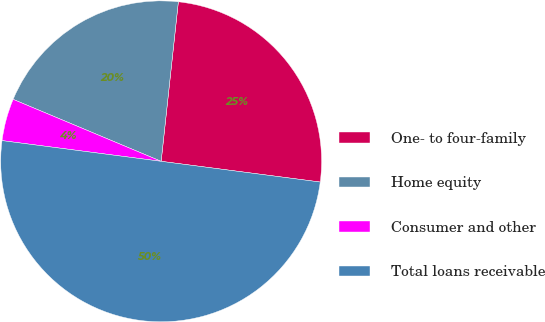Convert chart. <chart><loc_0><loc_0><loc_500><loc_500><pie_chart><fcel>One- to four-family<fcel>Home equity<fcel>Consumer and other<fcel>Total loans receivable<nl><fcel>25.35%<fcel>20.4%<fcel>4.25%<fcel>50.0%<nl></chart> 